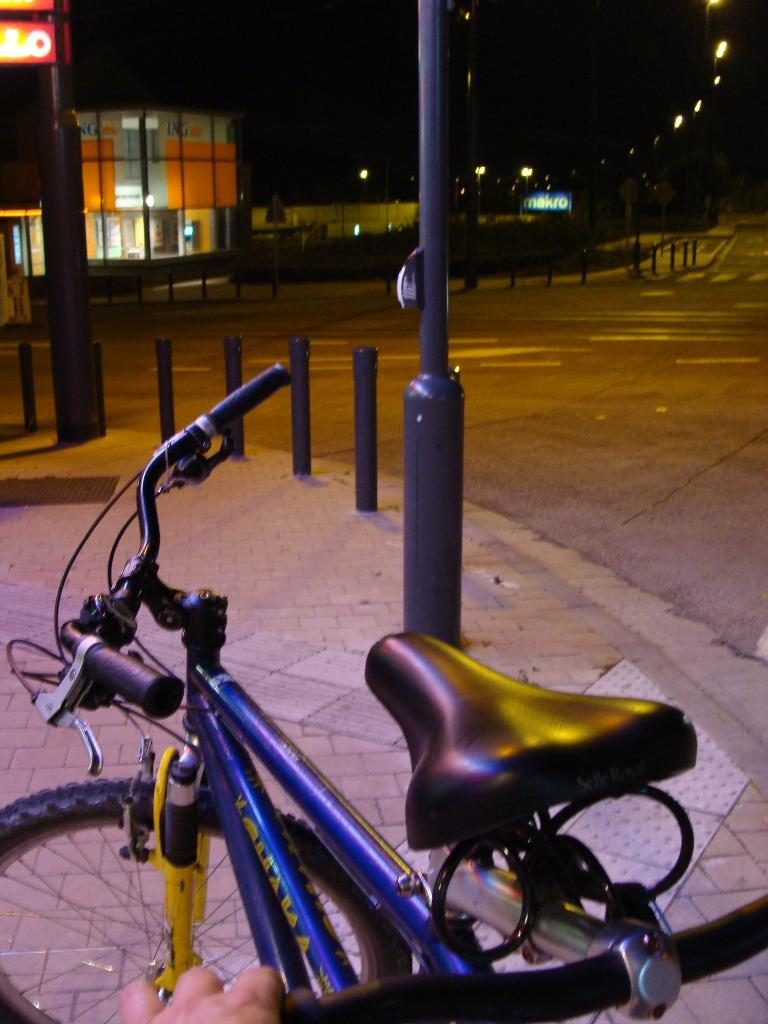What is the main object in the image? There is a bicycle in the image. What is in front of the bicycle? There are poles, boards, and light poles in front of the bicycle. What type of structure is visible in the image? There is a building in the image. How would you describe the lighting conditions in the image? The background of the image is dark. Can you see a ghost riding the bicycle in the image? No, there is no ghost present in the image. What type of cream is being used to lubricate the bicycle chain in the image? There is no cream or lubrication being applied to the bicycle chain in the image. 